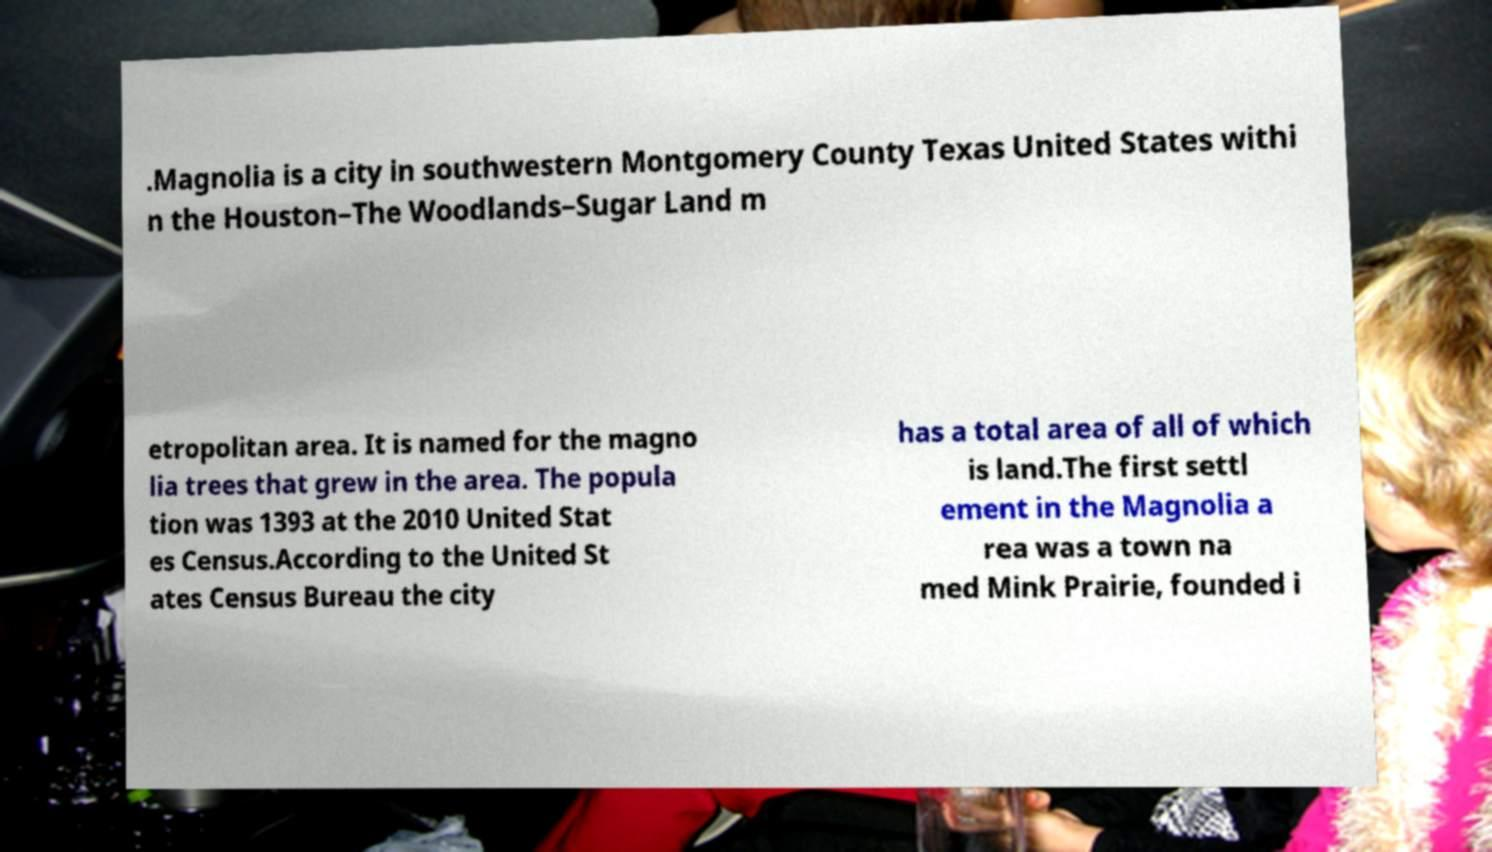I need the written content from this picture converted into text. Can you do that? .Magnolia is a city in southwestern Montgomery County Texas United States withi n the Houston–The Woodlands–Sugar Land m etropolitan area. It is named for the magno lia trees that grew in the area. The popula tion was 1393 at the 2010 United Stat es Census.According to the United St ates Census Bureau the city has a total area of all of which is land.The first settl ement in the Magnolia a rea was a town na med Mink Prairie, founded i 